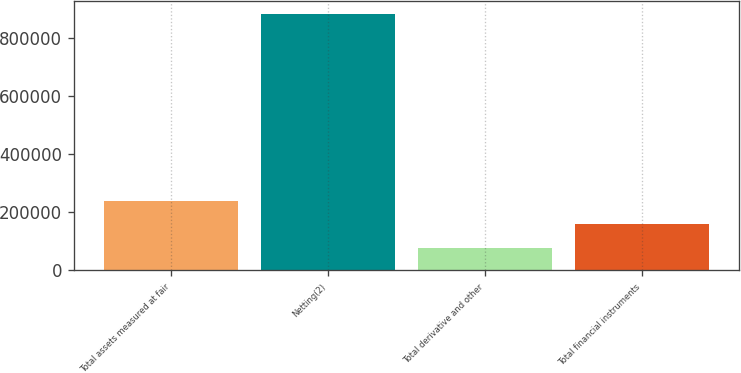<chart> <loc_0><loc_0><loc_500><loc_500><bar_chart><fcel>Total assets measured at fair<fcel>Netting(2)<fcel>Total derivative and other<fcel>Total financial instruments<nl><fcel>239350<fcel>883733<fcel>78254<fcel>158802<nl></chart> 